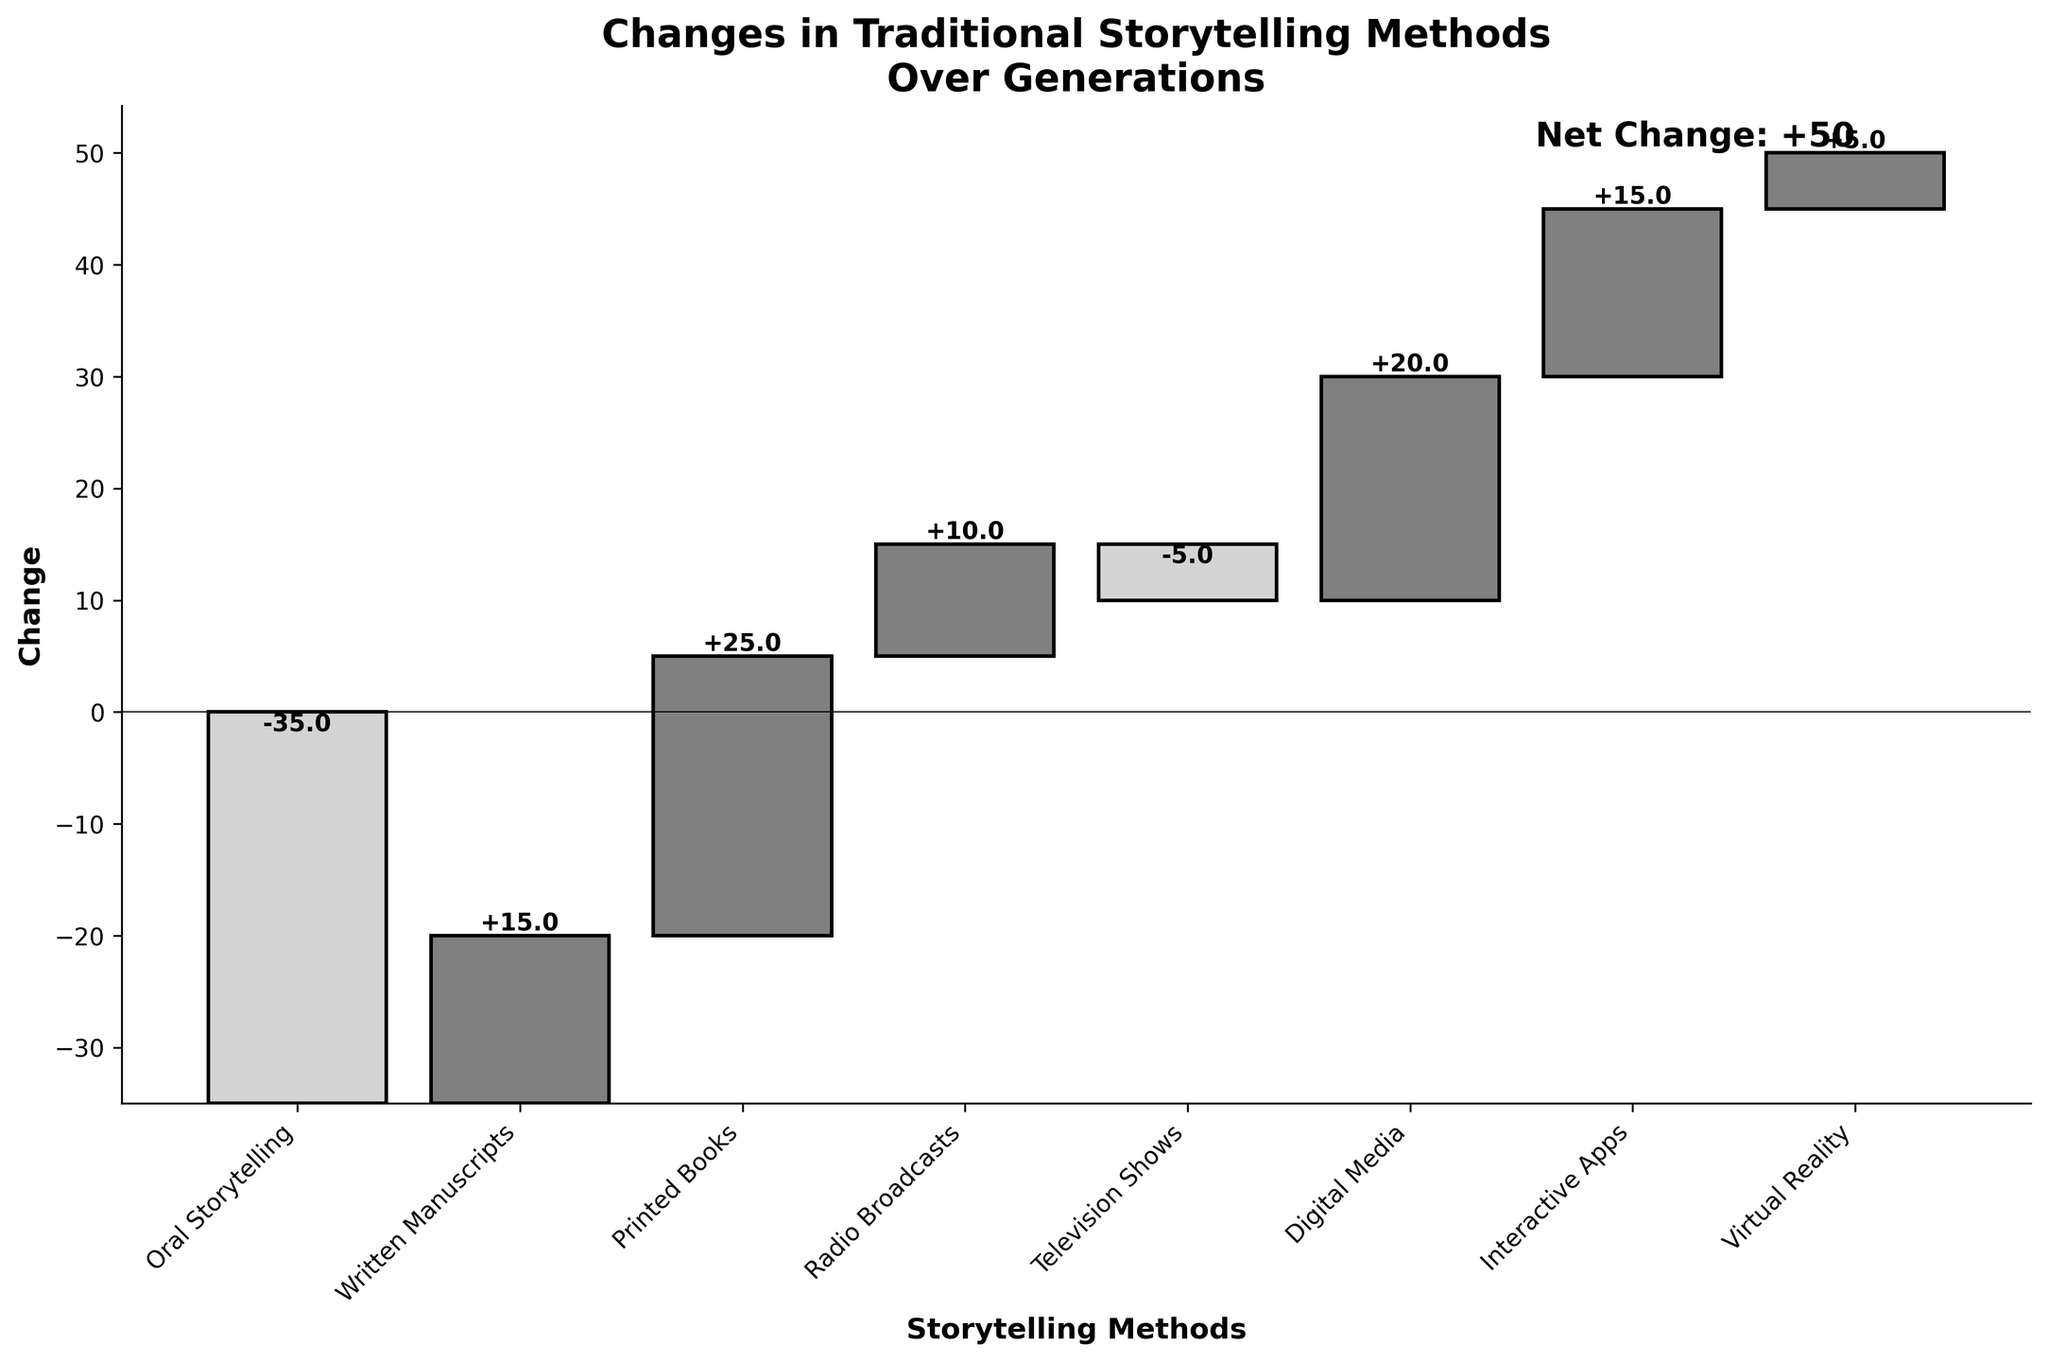what is the title of the figure? The title is located at the top of the figure. It states the main topic of the visualization.
Answer: Changes in Traditional Storytelling Methods Over Generations how many storytelling methods are listed in the figure? By counting the different categories on the x-axis, we can see the number of storytelling methods presented in the figure.
Answer: 7 which storytelling method has the highest positive change? By comparing the values associated with each storytelling method, we can identify the one with the highest positive change.
Answer: Printed Books what is the total positive change across all storytelling methods? To find the total positive change, sum up all the positive values: +15 (Written Manuscripts) + 25 (Printed Books) + 10 (Radio Broadcasts) + 20 (Digital Media) + 15 (Interactive Apps) + 5 (Virtual Reality).
Answer: 90 which storytelling methods have a negative change? The negative changes are indicated by the bars that extend downwards on the figure. By identifying these, we can determine the storytelling methods with negative changes.
Answer: Oral Storytelling, Television Shows what is the net change indicated in the figure? The net change is calculated by summing up all the changes. The figure provides this value directly for easy reference.
Answer: 50 how does the change in digital media compare to the change in interactive apps? By comparing the values associated with Digital Media and Interactive Apps, we can determine which has a higher or lower change.
Answer: Digital Media has a higher change by 5 which method declined the most over generations? By identifying the most negative value among the storytelling methods, we find the one that has declined the most.
Answer: Oral Storytelling if the trend continues, which storytelling method might face greater decline in the future? Considering current trends and the highest decline identified in the figure, we can predict future shifts.
Answer: Oral Storytelling 